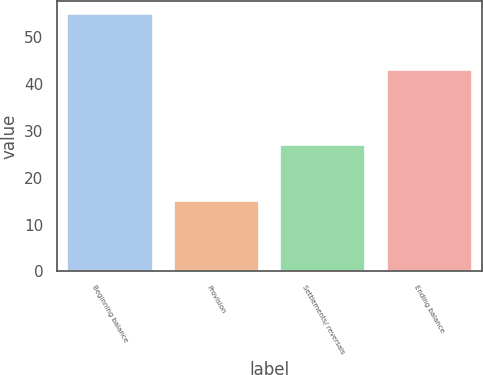<chart> <loc_0><loc_0><loc_500><loc_500><bar_chart><fcel>Beginning balance<fcel>Provision<fcel>Settlements/ reversals<fcel>Ending balance<nl><fcel>55<fcel>15<fcel>27<fcel>43<nl></chart> 